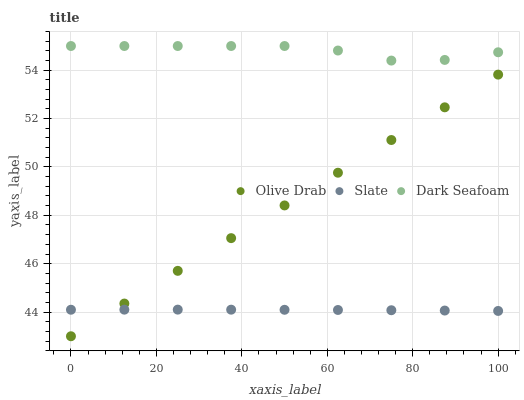Does Slate have the minimum area under the curve?
Answer yes or no. Yes. Does Dark Seafoam have the maximum area under the curve?
Answer yes or no. Yes. Does Olive Drab have the minimum area under the curve?
Answer yes or no. No. Does Olive Drab have the maximum area under the curve?
Answer yes or no. No. Is Olive Drab the smoothest?
Answer yes or no. Yes. Is Dark Seafoam the roughest?
Answer yes or no. Yes. Is Dark Seafoam the smoothest?
Answer yes or no. No. Is Olive Drab the roughest?
Answer yes or no. No. Does Olive Drab have the lowest value?
Answer yes or no. Yes. Does Dark Seafoam have the lowest value?
Answer yes or no. No. Does Dark Seafoam have the highest value?
Answer yes or no. Yes. Does Olive Drab have the highest value?
Answer yes or no. No. Is Olive Drab less than Dark Seafoam?
Answer yes or no. Yes. Is Dark Seafoam greater than Olive Drab?
Answer yes or no. Yes. Does Slate intersect Olive Drab?
Answer yes or no. Yes. Is Slate less than Olive Drab?
Answer yes or no. No. Is Slate greater than Olive Drab?
Answer yes or no. No. Does Olive Drab intersect Dark Seafoam?
Answer yes or no. No. 